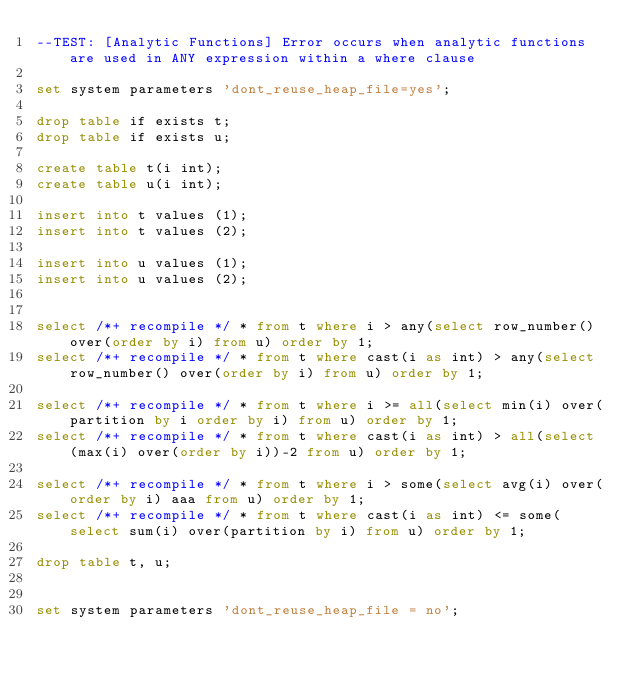Convert code to text. <code><loc_0><loc_0><loc_500><loc_500><_SQL_>--TEST: [Analytic Functions] Error occurs when analytic functions are used in ANY expression within a where clause

set system parameters 'dont_reuse_heap_file=yes';

drop table if exists t;
drop table if exists u;

create table t(i int);
create table u(i int);

insert into t values (1);
insert into t values (2);

insert into u values (1);
insert into u values (2);


select /*+ recompile */ * from t where i > any(select row_number() over(order by i) from u) order by 1;
select /*+ recompile */ * from t where cast(i as int) > any(select row_number() over(order by i) from u) order by 1;

select /*+ recompile */ * from t where i >= all(select min(i) over(partition by i order by i) from u) order by 1;
select /*+ recompile */ * from t where cast(i as int) > all(select (max(i) over(order by i))-2 from u) order by 1;

select /*+ recompile */ * from t where i > some(select avg(i) over(order by i) aaa from u) order by 1;
select /*+ recompile */ * from t where cast(i as int) <= some(select sum(i) over(partition by i) from u) order by 1;

drop table t, u;


set system parameters 'dont_reuse_heap_file = no';
</code> 